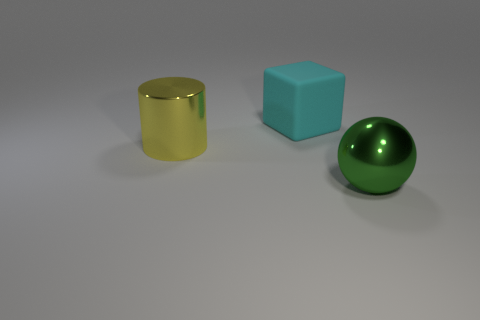Add 3 yellow metallic cylinders. How many objects exist? 6 Subtract all blocks. How many objects are left? 2 Subtract 1 green balls. How many objects are left? 2 Subtract all large yellow rubber things. Subtract all large green things. How many objects are left? 2 Add 2 green objects. How many green objects are left? 3 Add 1 large yellow cylinders. How many large yellow cylinders exist? 2 